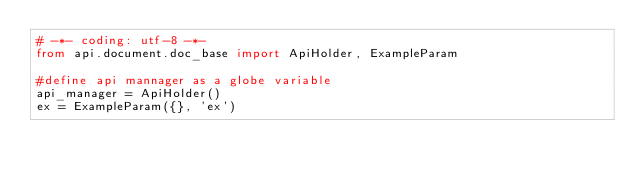<code> <loc_0><loc_0><loc_500><loc_500><_Python_># -*- coding: utf-8 -*-
from api.document.doc_base import ApiHolder, ExampleParam

#define api mannager as a globe variable
api_manager = ApiHolder()
ex = ExampleParam({}, 'ex')
</code> 